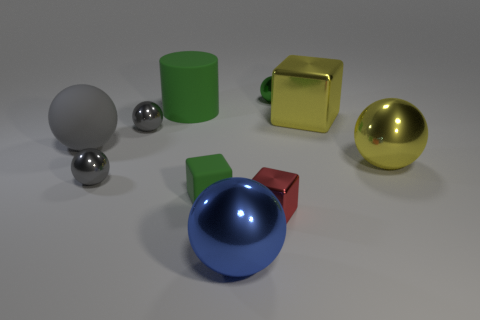Is there a metallic sphere that has the same size as the green block?
Your answer should be compact. Yes. What number of things are small green things on the left side of the small green ball or tiny balls in front of the green cylinder?
Ensure brevity in your answer.  3. There is a metal block that is in front of the large yellow shiny object that is behind the big gray matte ball; what color is it?
Offer a very short reply. Red. What color is the small block that is the same material as the big yellow cube?
Give a very brief answer. Red. How many rubber cubes are the same color as the large rubber ball?
Make the answer very short. 0. How many things are either small rubber things or small objects?
Give a very brief answer. 5. There is a gray matte object that is the same size as the green matte cylinder; what shape is it?
Offer a terse response. Sphere. How many metallic objects are left of the yellow metallic cube and on the right side of the big blue object?
Give a very brief answer. 2. There is a object that is in front of the small red shiny cube; what is it made of?
Your answer should be compact. Metal. What is the size of the green object that is made of the same material as the red cube?
Make the answer very short. Small. 